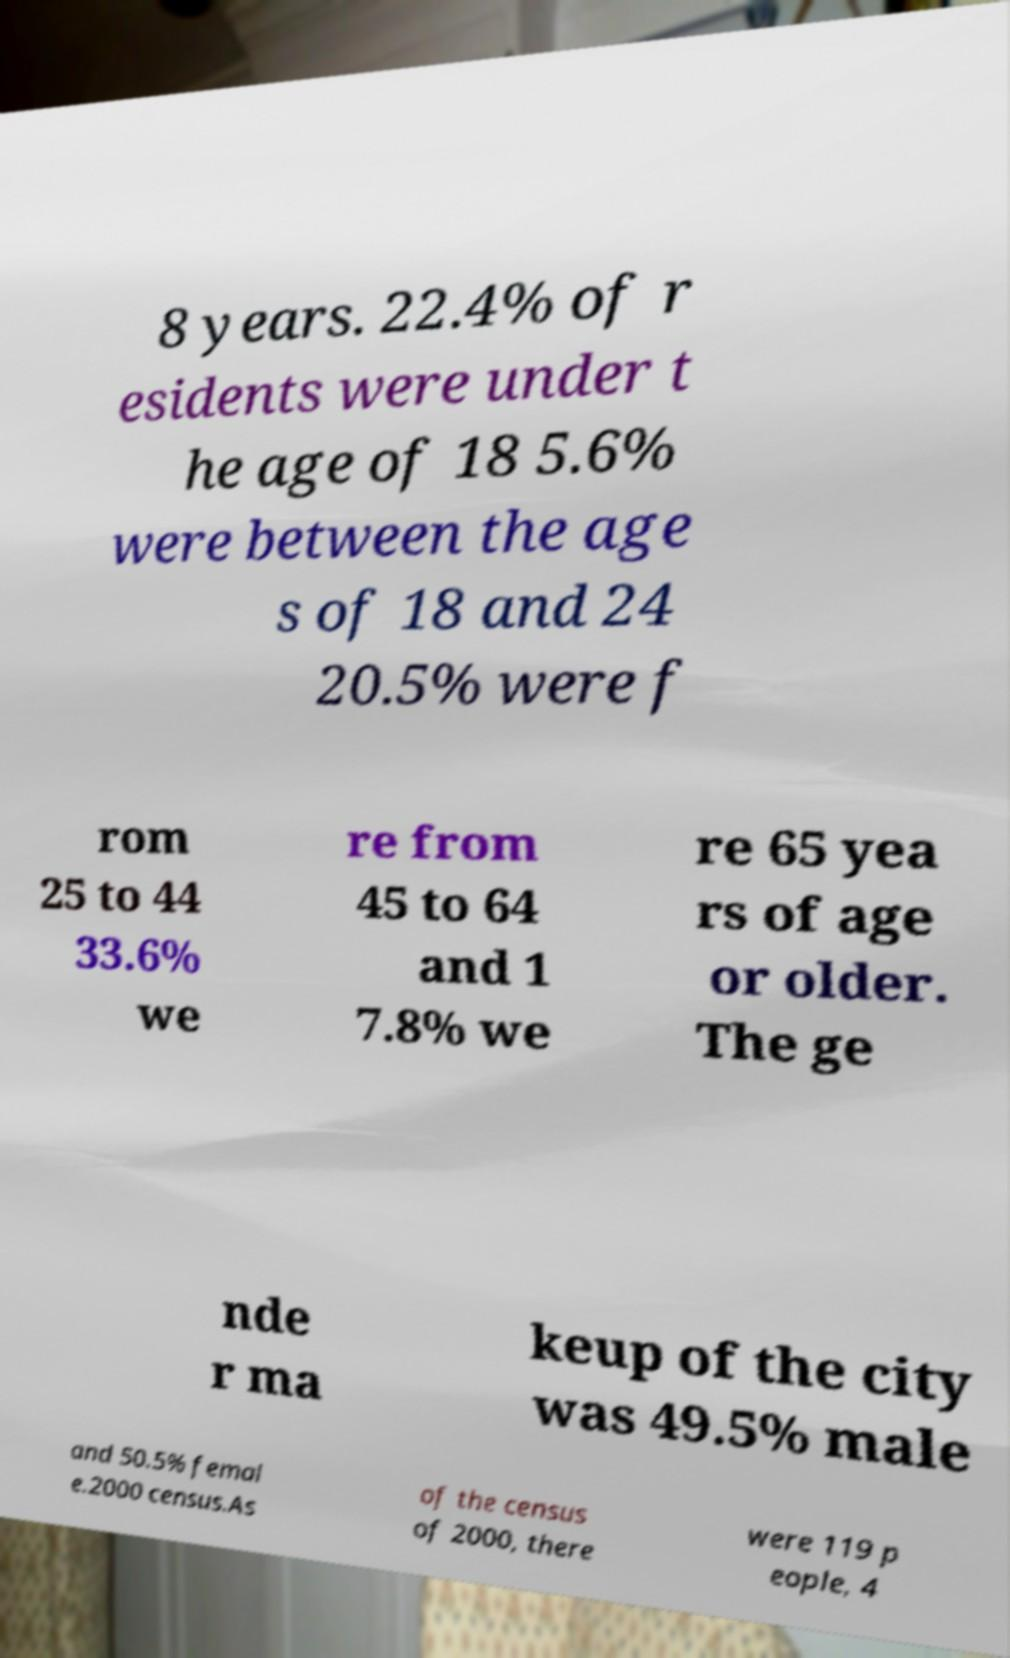Could you assist in decoding the text presented in this image and type it out clearly? 8 years. 22.4% of r esidents were under t he age of 18 5.6% were between the age s of 18 and 24 20.5% were f rom 25 to 44 33.6% we re from 45 to 64 and 1 7.8% we re 65 yea rs of age or older. The ge nde r ma keup of the city was 49.5% male and 50.5% femal e.2000 census.As of the census of 2000, there were 119 p eople, 4 